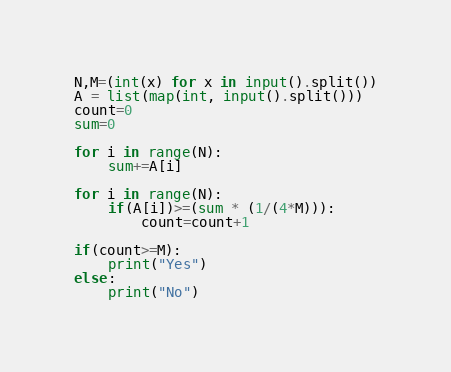<code> <loc_0><loc_0><loc_500><loc_500><_Python_>N,M=(int(x) for x in input().split())
A = list(map(int, input().split()))
count=0
sum=0

for i in range(N):
    sum+=A[i]

for i in range(N):
    if(A[i])>=(sum * (1/(4*M))):
        count=count+1

if(count>=M):
    print("Yes")
else:
    print("No")
</code> 